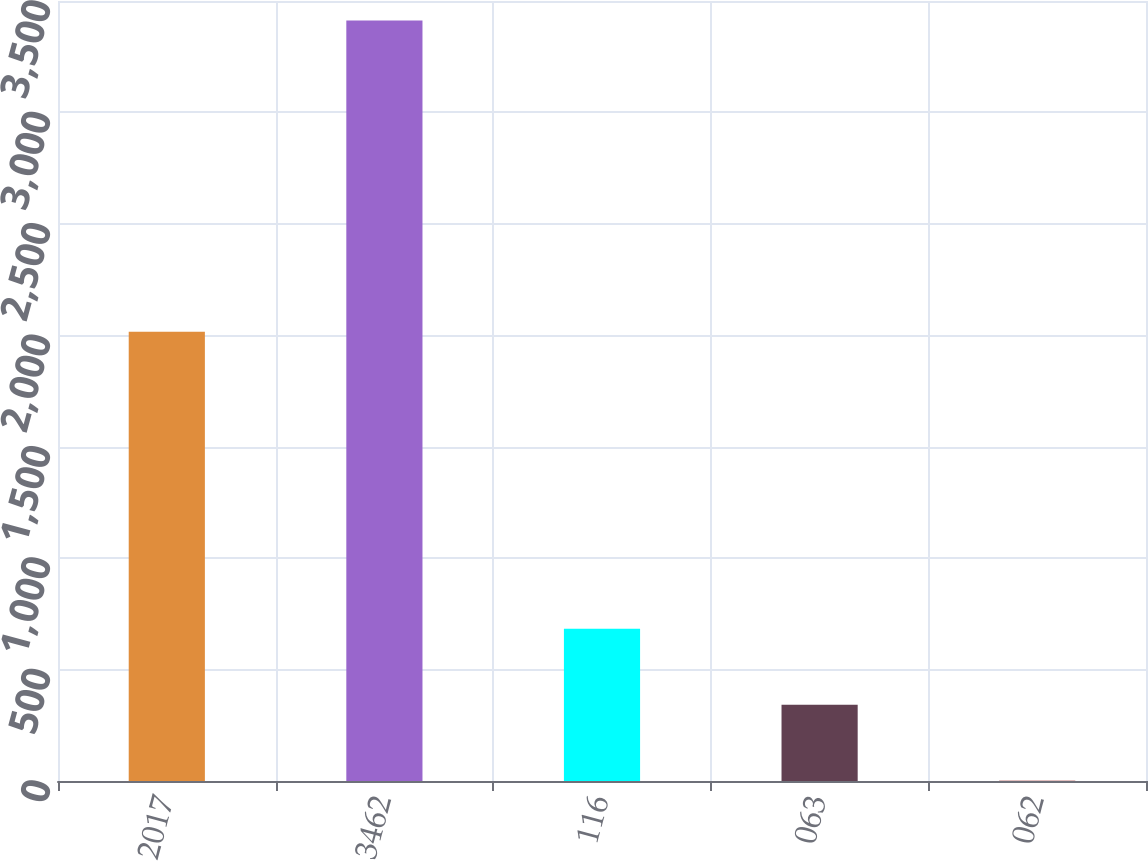<chart> <loc_0><loc_0><loc_500><loc_500><bar_chart><fcel>2017<fcel>3462<fcel>116<fcel>063<fcel>062<nl><fcel>2016<fcel>3413<fcel>683.61<fcel>342.43<fcel>1.25<nl></chart> 